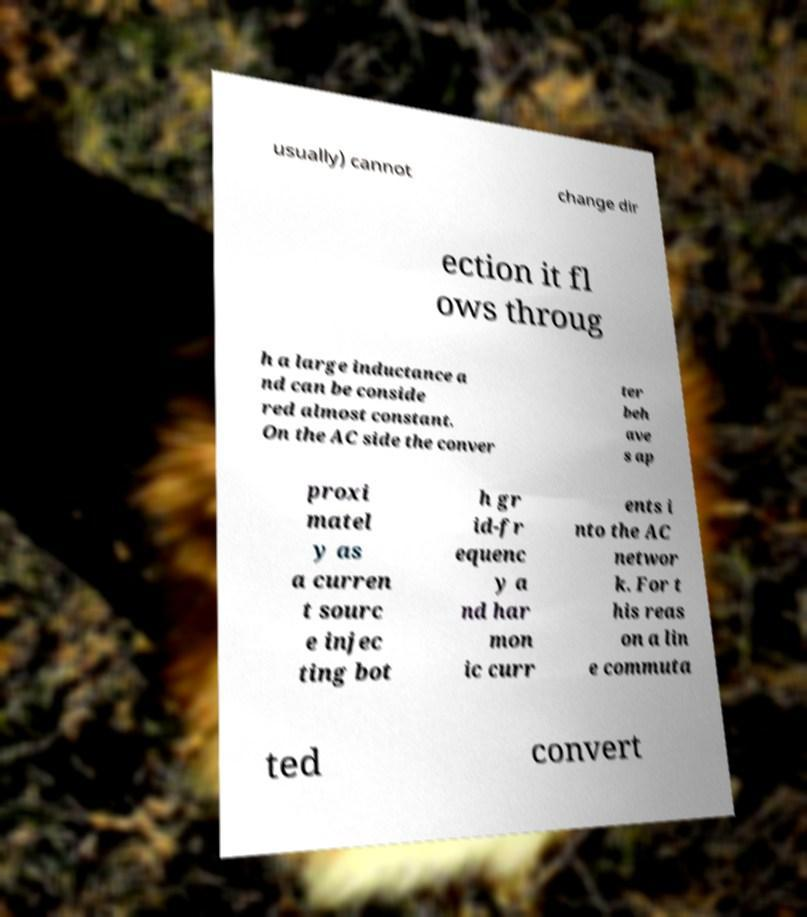For documentation purposes, I need the text within this image transcribed. Could you provide that? usually) cannot change dir ection it fl ows throug h a large inductance a nd can be conside red almost constant. On the AC side the conver ter beh ave s ap proxi matel y as a curren t sourc e injec ting bot h gr id-fr equenc y a nd har mon ic curr ents i nto the AC networ k. For t his reas on a lin e commuta ted convert 